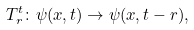<formula> <loc_0><loc_0><loc_500><loc_500>T _ { r } ^ { t } \colon \psi ( x , t ) \rightarrow \psi ( x , t - r ) ,</formula> 